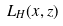Convert formula to latex. <formula><loc_0><loc_0><loc_500><loc_500>L _ { H } ( x , z )</formula> 